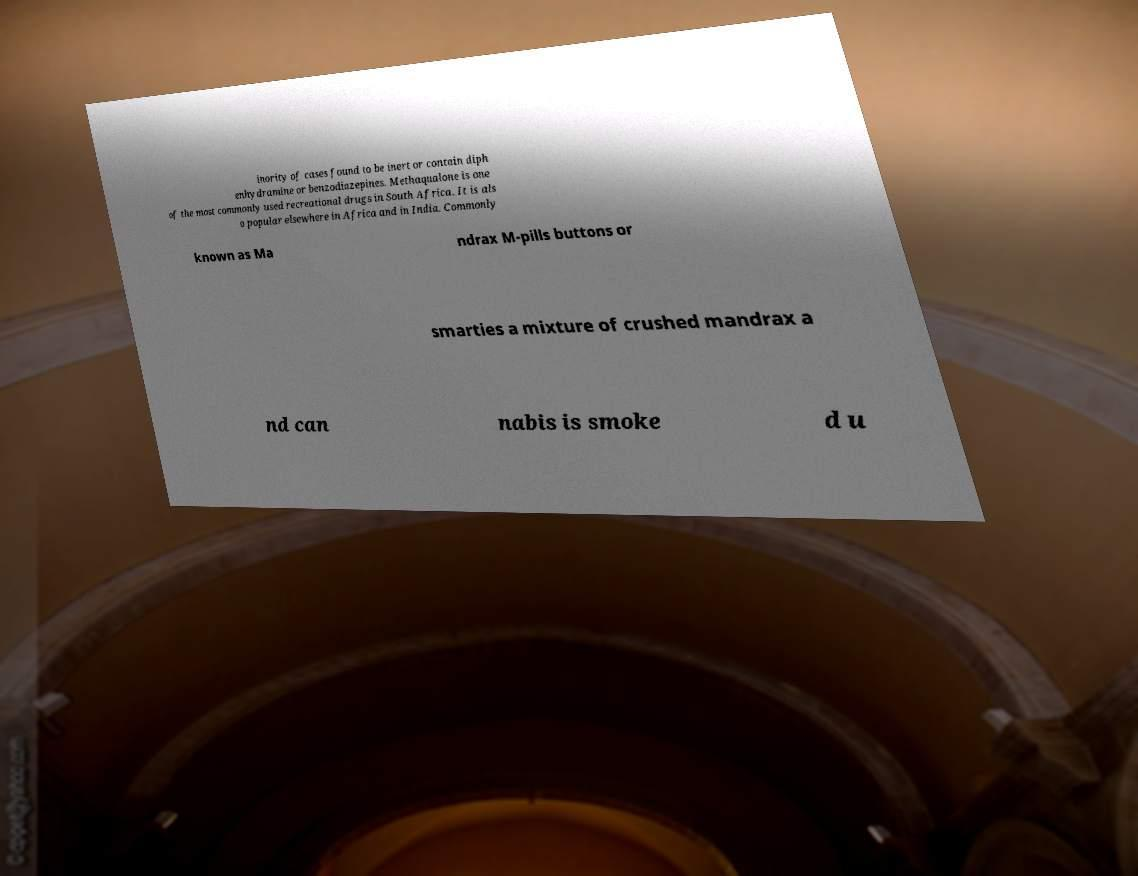Can you read and provide the text displayed in the image?This photo seems to have some interesting text. Can you extract and type it out for me? inority of cases found to be inert or contain diph enhydramine or benzodiazepines. Methaqualone is one of the most commonly used recreational drugs in South Africa. It is als o popular elsewhere in Africa and in India. Commonly known as Ma ndrax M-pills buttons or smarties a mixture of crushed mandrax a nd can nabis is smoke d u 